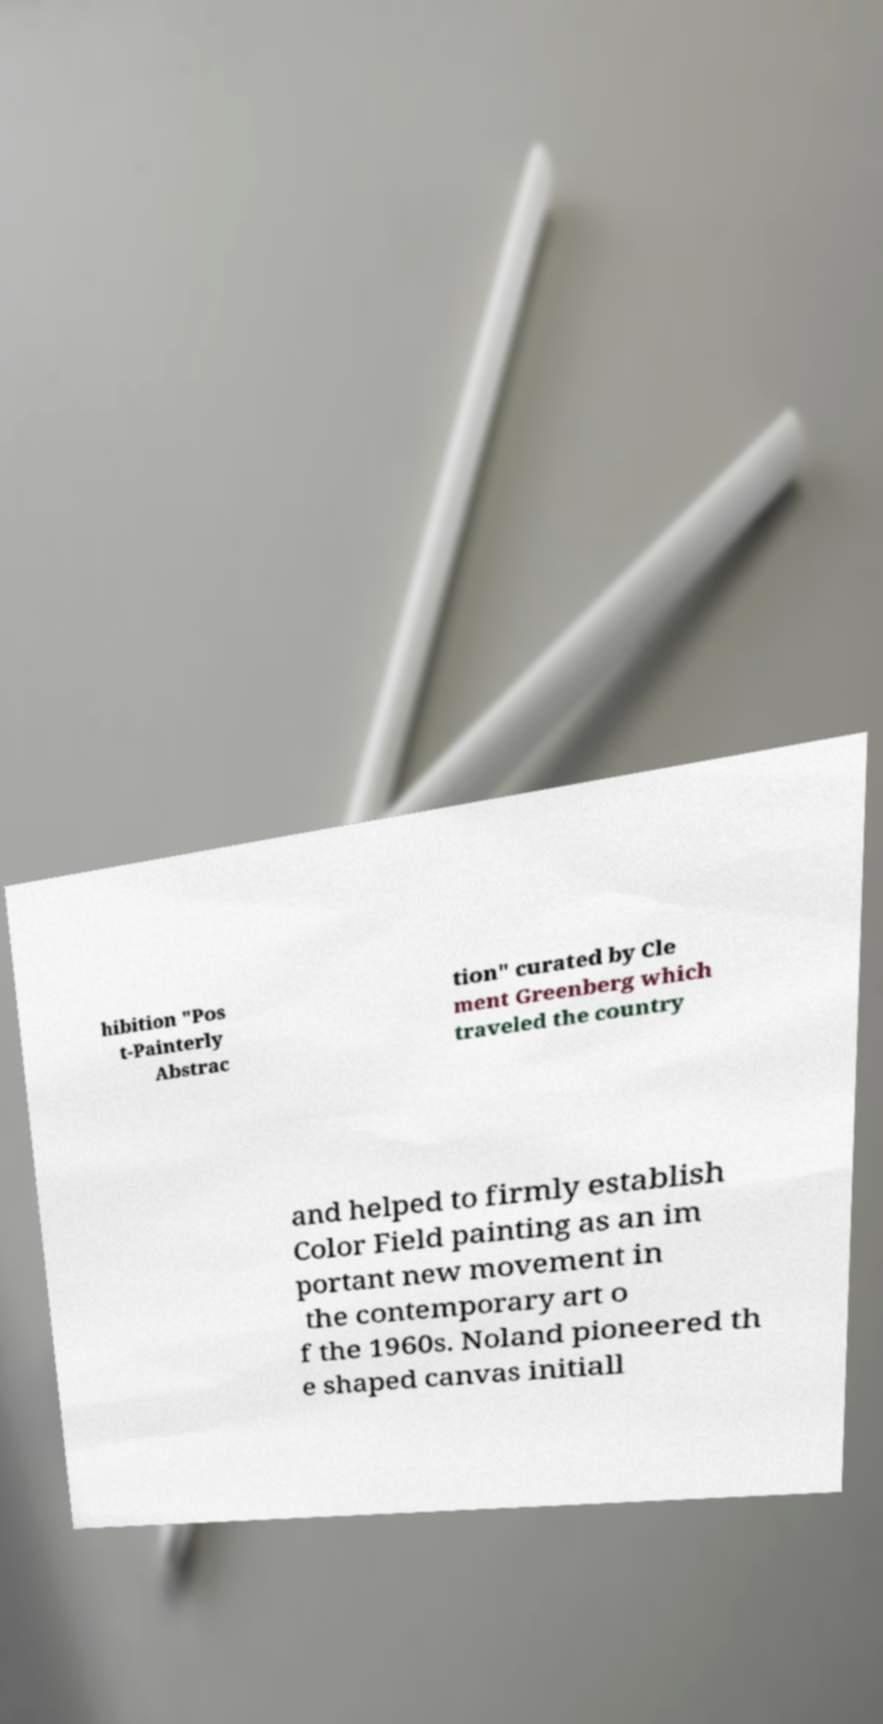Please identify and transcribe the text found in this image. hibition "Pos t-Painterly Abstrac tion" curated by Cle ment Greenberg which traveled the country and helped to firmly establish Color Field painting as an im portant new movement in the contemporary art o f the 1960s. Noland pioneered th e shaped canvas initiall 